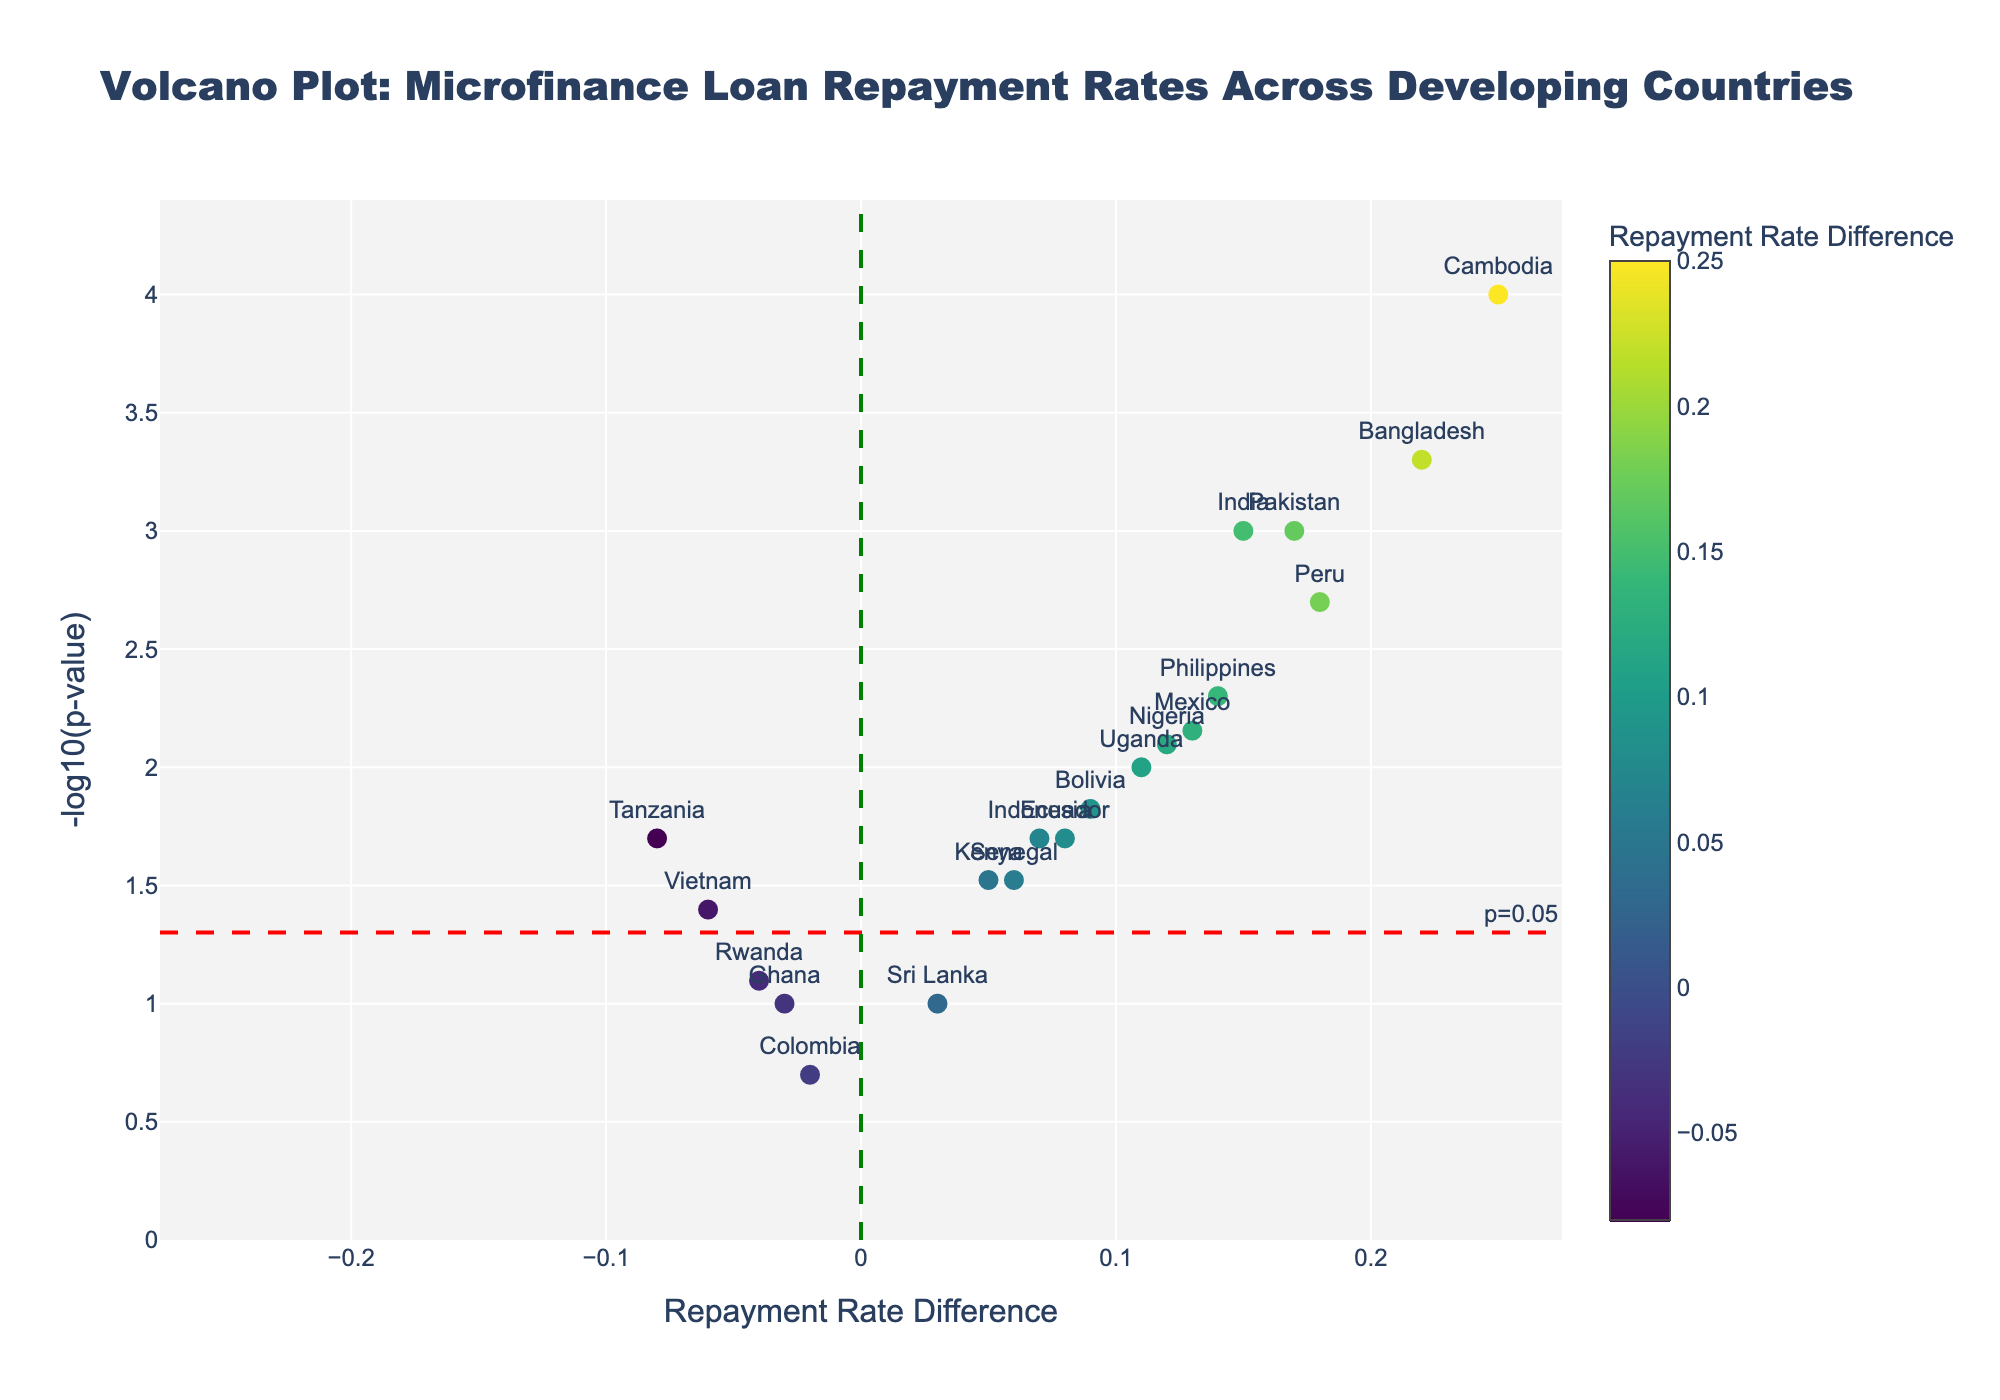What is the title of the plot? The title is usually located at the top of the figure. In this case, it should be clearly stated.
Answer: Volcano Plot: Microfinance Loan Repayment Rates Across Developing Countries How many countries have a significant difference in repayment rates? A significant difference is commonly considered when the p-value < 0.05, which corresponds to -log10(p-value) > 1.3. By counting the data points above the dashed red line that represents this threshold, we find there are 13 countries.
Answer: 13 Which country shows the largest positive repayment rate difference? To identify the largest positive difference, check the data point furthest to the right on the plot. Based on the x-axis, Cambodia has the largest positive repayment rate difference.
Answer: Cambodia Which country has the highest -log10(p-value)? The -log10(p-value) is represented on the y-axis. The highest point on this axis identifies Cambodia as having the highest -log10(p-value).
Answer: Cambodia What is the repayment rate difference for the country with the smallest significant -log10(p-value)? Locate the lowest point above the significance threshold line (-log10(p-value) > 1.3). Vietnam with a -log10(p-value) around 1.3 has a repayment rate difference of -0.06.
Answer: -0.06 Between India and Nigeria, which has a more significant repayment rate difference? The significance relates to the p-value. Compare the -log10(p-value) values for India and Nigeria. India has a -log10(p-value) of 3, while Nigeria's value is around 2.13. Therefore, India is more significant.
Answer: India Which countries show a negative repayment rate difference? The negative repayment rate differences are shown to the left of the vertical green line (x=0). The countries are Tanzania, Vietnam, Rwanda, Colombia, and Ghana.
Answer: Tanzania, Vietnam, Rwanda, Colombia, Ghana How many countries have a repayment rate difference between 0.1 and 0.2? Look along the x-axis for data points within the range 0.1 to 0.2. India (0.15), Nigeria (0.12), Peru (0.18), and Pakistan (0.17), totaling 4 countries.
Answer: 4 What is the -log10(p-value) for Bangladesh? Find Bangladesh in the plot, which shows a -log10(p-value) of around 3.30.
Answer: 3.30 